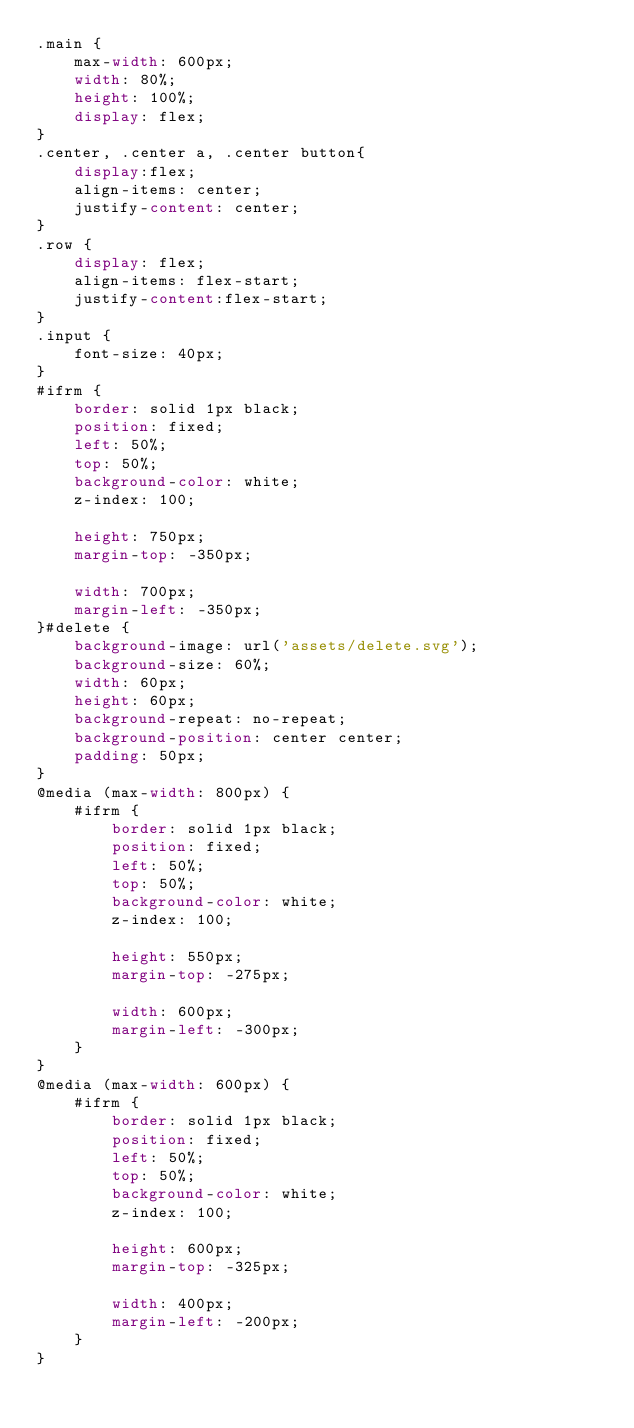Convert code to text. <code><loc_0><loc_0><loc_500><loc_500><_CSS_>.main {
    max-width: 600px;
    width: 80%;
    height: 100%;
    display: flex;
}
.center, .center a, .center button{
    display:flex;
    align-items: center;
    justify-content: center;
}
.row {
    display: flex;
    align-items: flex-start;
    justify-content:flex-start;
}
.input {
    font-size: 40px;
}
#ifrm {
    border: solid 1px black;
    position: fixed;
    left: 50%;
    top: 50%;
    background-color: white;
    z-index: 100;

    height: 750px;
    margin-top: -350px;

    width: 700px;
    margin-left: -350px;
}#delete {
    background-image: url('assets/delete.svg');
    background-size: 60%;
    width: 60px;
    height: 60px;
    background-repeat: no-repeat;
    background-position: center center;
    padding: 50px;
}
@media (max-width: 800px) {
    #ifrm {
        border: solid 1px black;
        position: fixed;
        left: 50%;
        top: 50%;
        background-color: white;
        z-index: 100;
            
        height: 550px;
        margin-top: -275px;

        width: 600px;
        margin-left: -300px;
    }
}
@media (max-width: 600px) {
    #ifrm {
        border: solid 1px black;
        position: fixed;
        left: 50%;
        top: 50%;
        background-color: white;
        z-index: 100;
            
        height: 600px;
        margin-top: -325px;

        width: 400px;
        margin-left: -200px;
    }
}</code> 